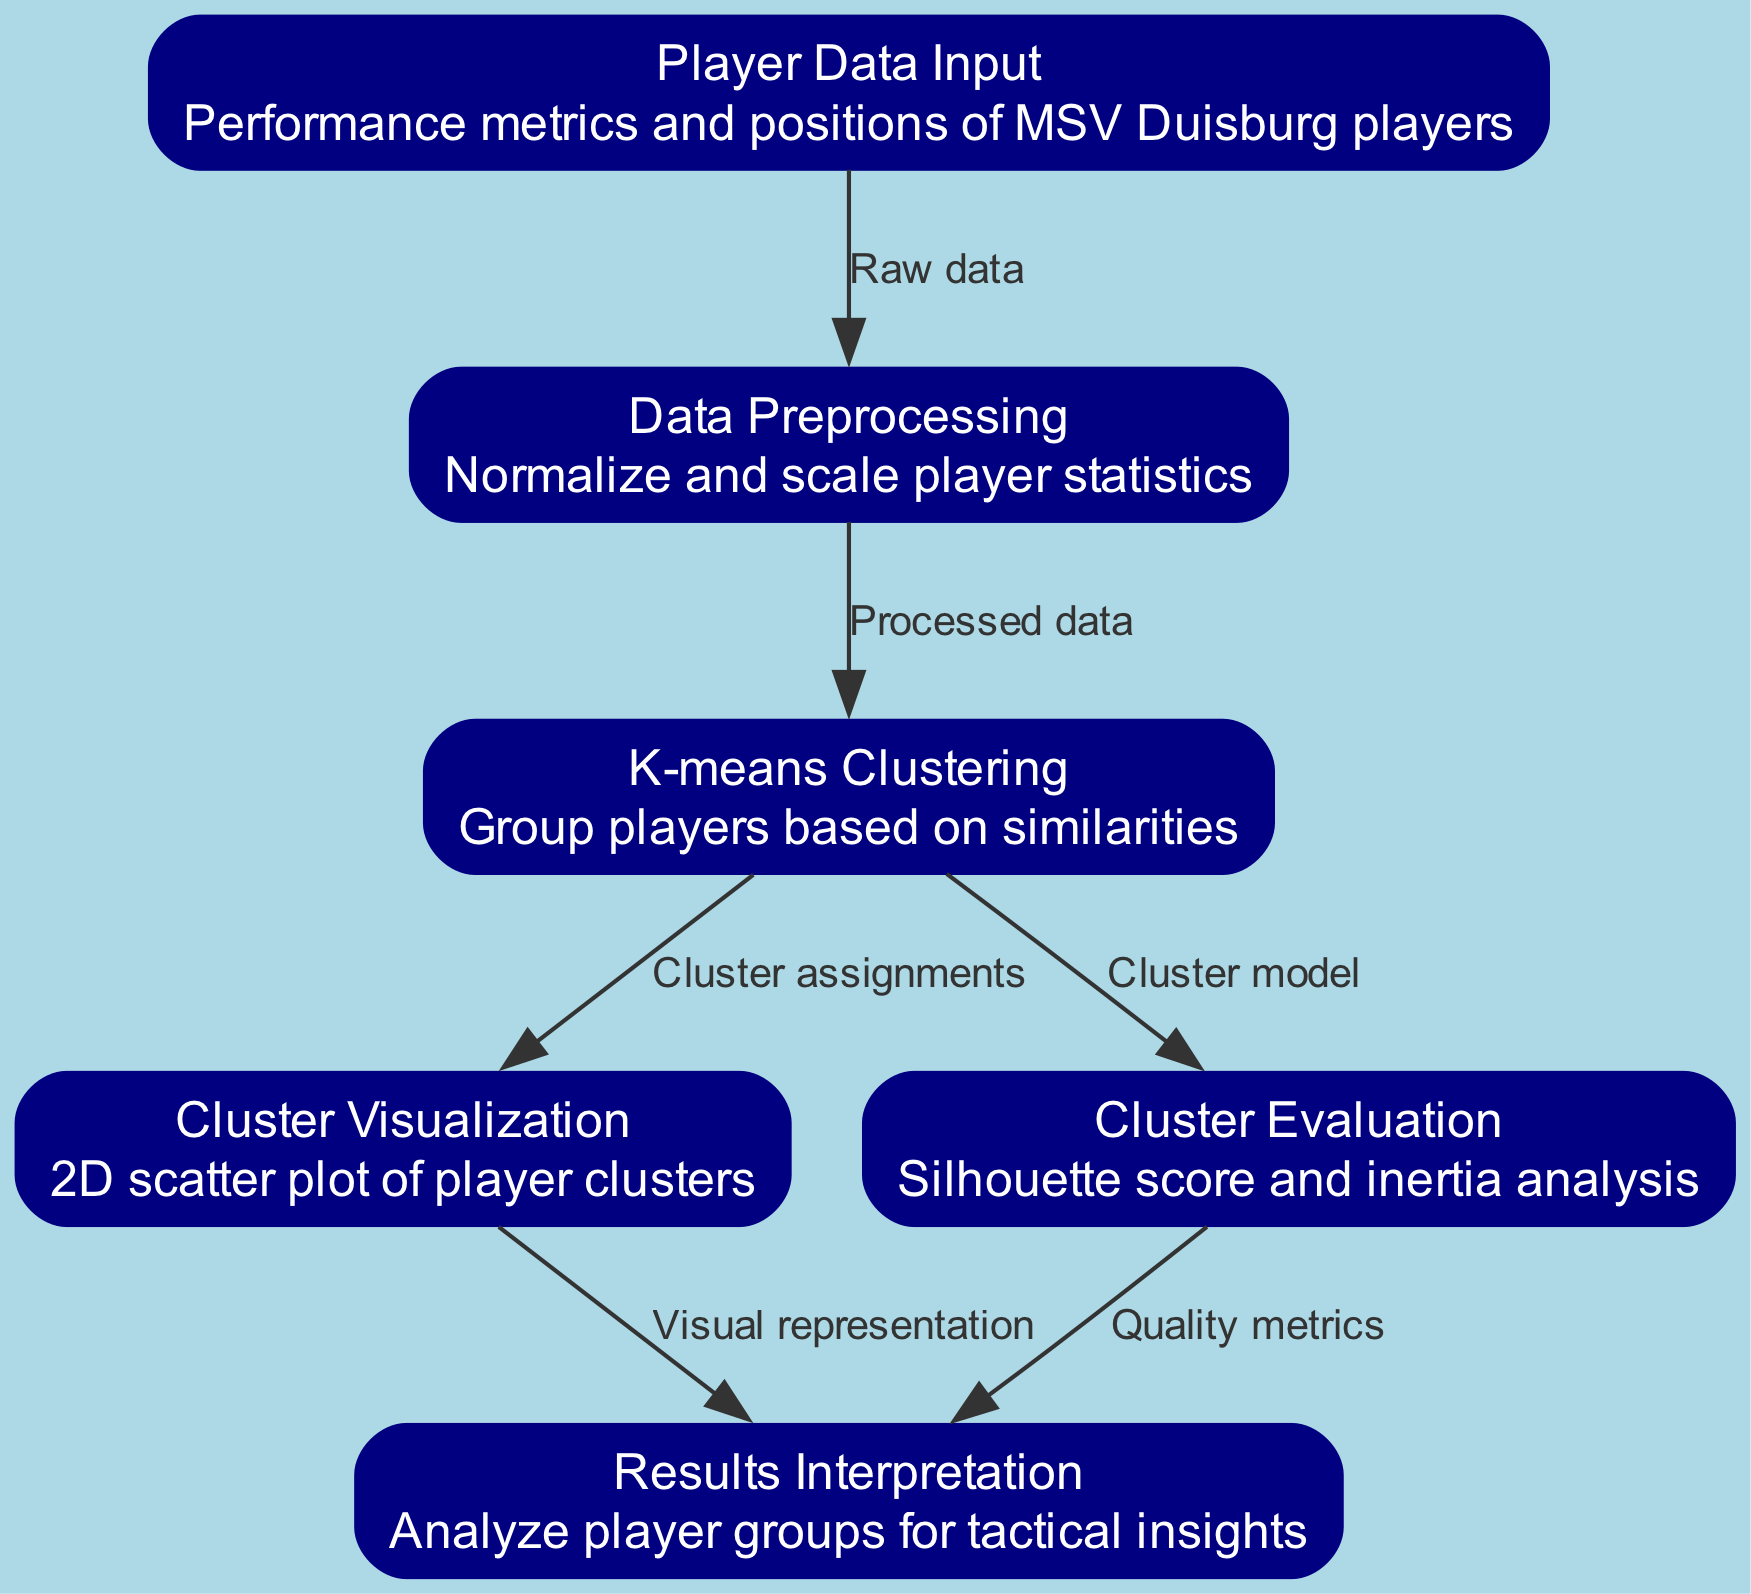What is the first step in the diagram? The first step is labeled "Player Data Input," which indicates that the process begins with the input of player performance metrics and positions.
Answer: Player Data Input How many nodes are there in total? Counting the nodes listed, there are six nodes in total: Player Data Input, Data Preprocessing, K-means Clustering, Cluster Visualization, Cluster Evaluation, and Results Interpretation.
Answer: Six What flows from Data Preprocessing to K-means Clustering? The flow from Data Preprocessing to K-means Clustering is labeled "Processed data," indicating the data that has undergone normalization and scaling.
Answer: Processed data Which node represents the analysis of player groups? The node labeled "Results Interpretation" represents the analysis of player groups for tactical insights based on the clustering results.
Answer: Results Interpretation What evaluation metrics are mentioned in the diagram? The diagram mentions "Silhouette score and inertia analysis" as the evaluation metrics used to assess the quality of the clusters formed during the K-means Clustering.
Answer: Silhouette score and inertia analysis How does Cluster Visualization relate to Results Interpretation? Cluster Visualization provides a "Visual representation" for the player clusters, which is then used in the Results Interpretation to analyze the player groupings for tactical insights.
Answer: Visual representation What is the main purpose of K-means Clustering in this diagram? The main purpose of K-means Clustering is to "Group players based on similarities," which is key to the clustering analysis performed on the players’ data.
Answer: Group players based on similarities What step comes after Cluster Evaluation? After Cluster Evaluation, the next step in the diagram is "Results Interpretation," where the analysis of player groupings occurs based on the evaluation metrics.
Answer: Results Interpretation What type of visualization is used in the diagram? The type of visualization used in the diagram is a "2D scatter plot," which represents the clusters of players based on their performance metrics.
Answer: 2D scatter plot 